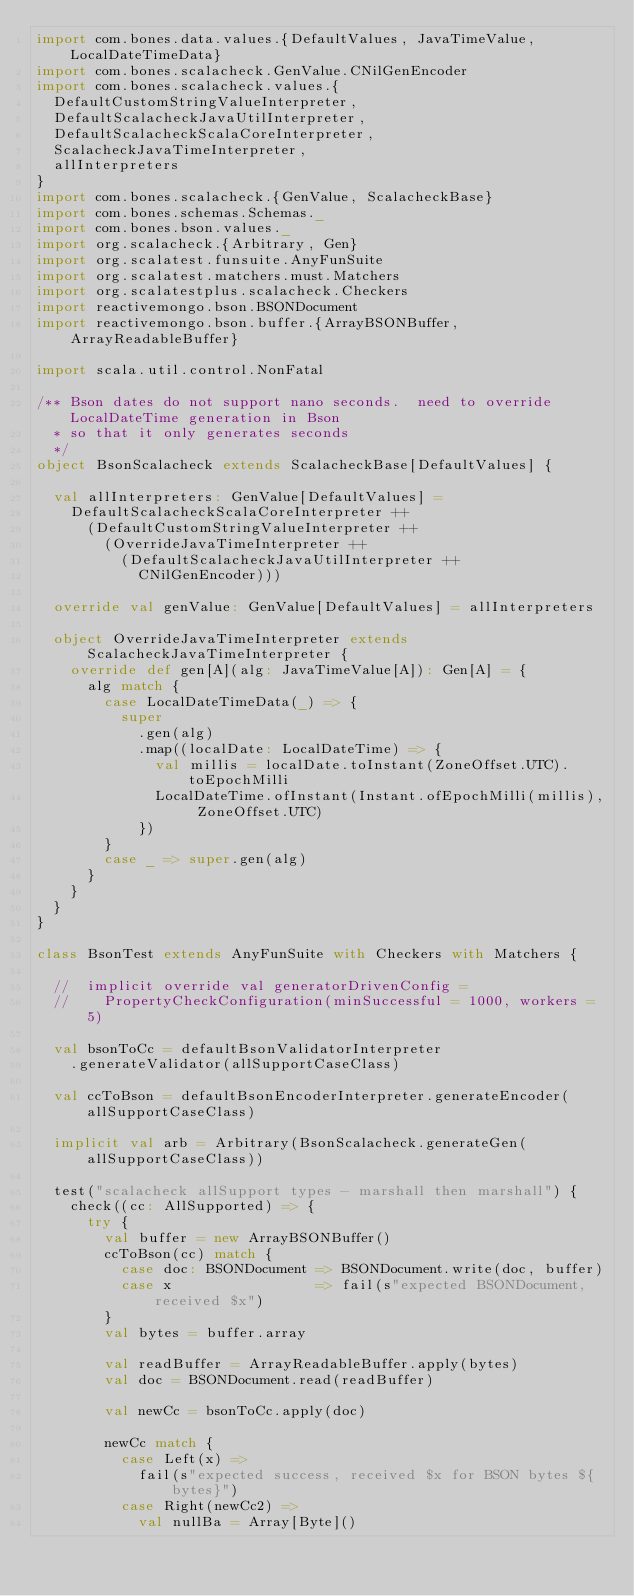Convert code to text. <code><loc_0><loc_0><loc_500><loc_500><_Scala_>import com.bones.data.values.{DefaultValues, JavaTimeValue, LocalDateTimeData}
import com.bones.scalacheck.GenValue.CNilGenEncoder
import com.bones.scalacheck.values.{
  DefaultCustomStringValueInterpreter,
  DefaultScalacheckJavaUtilInterpreter,
  DefaultScalacheckScalaCoreInterpreter,
  ScalacheckJavaTimeInterpreter,
  allInterpreters
}
import com.bones.scalacheck.{GenValue, ScalacheckBase}
import com.bones.schemas.Schemas._
import com.bones.bson.values._
import org.scalacheck.{Arbitrary, Gen}
import org.scalatest.funsuite.AnyFunSuite
import org.scalatest.matchers.must.Matchers
import org.scalatestplus.scalacheck.Checkers
import reactivemongo.bson.BSONDocument
import reactivemongo.bson.buffer.{ArrayBSONBuffer, ArrayReadableBuffer}

import scala.util.control.NonFatal

/** Bson dates do not support nano seconds.  need to override LocalDateTime generation in Bson
  * so that it only generates seconds
  */
object BsonScalacheck extends ScalacheckBase[DefaultValues] {

  val allInterpreters: GenValue[DefaultValues] =
    DefaultScalacheckScalaCoreInterpreter ++
      (DefaultCustomStringValueInterpreter ++
        (OverrideJavaTimeInterpreter ++
          (DefaultScalacheckJavaUtilInterpreter ++
            CNilGenEncoder)))

  override val genValue: GenValue[DefaultValues] = allInterpreters

  object OverrideJavaTimeInterpreter extends ScalacheckJavaTimeInterpreter {
    override def gen[A](alg: JavaTimeValue[A]): Gen[A] = {
      alg match {
        case LocalDateTimeData(_) => {
          super
            .gen(alg)
            .map((localDate: LocalDateTime) => {
              val millis = localDate.toInstant(ZoneOffset.UTC).toEpochMilli
              LocalDateTime.ofInstant(Instant.ofEpochMilli(millis), ZoneOffset.UTC)
            })
        }
        case _ => super.gen(alg)
      }
    }
  }
}

class BsonTest extends AnyFunSuite with Checkers with Matchers {

  //  implicit override val generatorDrivenConfig =
  //    PropertyCheckConfiguration(minSuccessful = 1000, workers = 5)

  val bsonToCc = defaultBsonValidatorInterpreter
    .generateValidator(allSupportCaseClass)

  val ccToBson = defaultBsonEncoderInterpreter.generateEncoder(allSupportCaseClass)

  implicit val arb = Arbitrary(BsonScalacheck.generateGen(allSupportCaseClass))

  test("scalacheck allSupport types - marshall then marshall") {
    check((cc: AllSupported) => {
      try {
        val buffer = new ArrayBSONBuffer()
        ccToBson(cc) match {
          case doc: BSONDocument => BSONDocument.write(doc, buffer)
          case x                 => fail(s"expected BSONDocument, received $x")
        }
        val bytes = buffer.array

        val readBuffer = ArrayReadableBuffer.apply(bytes)
        val doc = BSONDocument.read(readBuffer)

        val newCc = bsonToCc.apply(doc)

        newCc match {
          case Left(x) =>
            fail(s"expected success, received $x for BSON bytes ${bytes}")
          case Right(newCc2) =>
            val nullBa = Array[Byte]()
</code> 